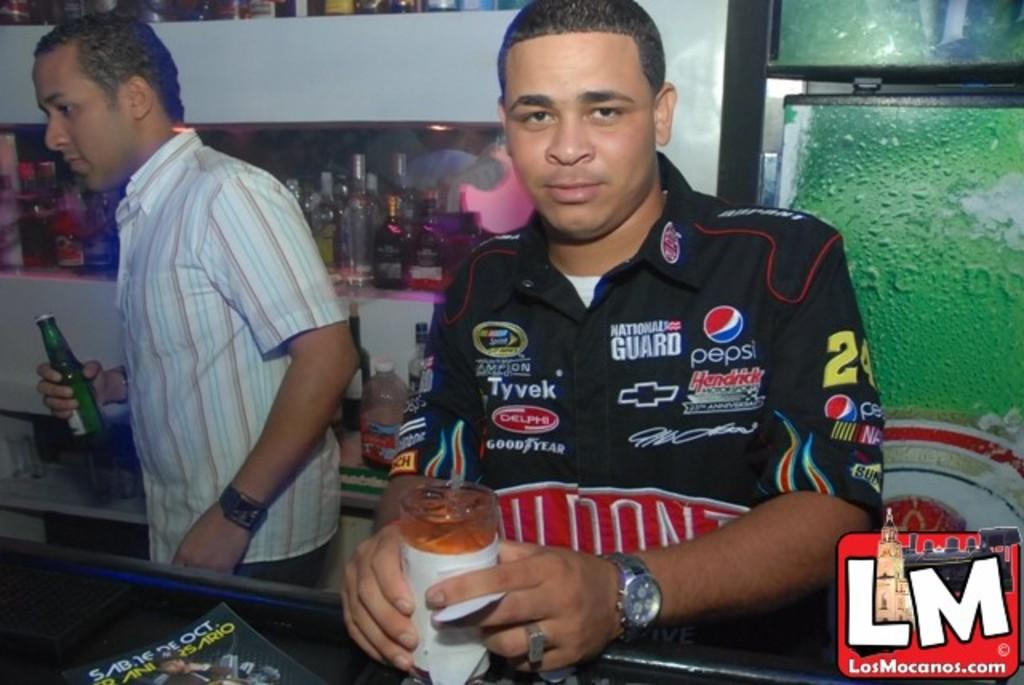How many people are in the image? There are two men in the image. What is one of the men holding in his hand? One of the men is holding a glass bottle in his hand. What type of pets are visible in the image? There are no pets visible in the image. Can you see a tiger in the image? No, there is no tiger present in the image. 